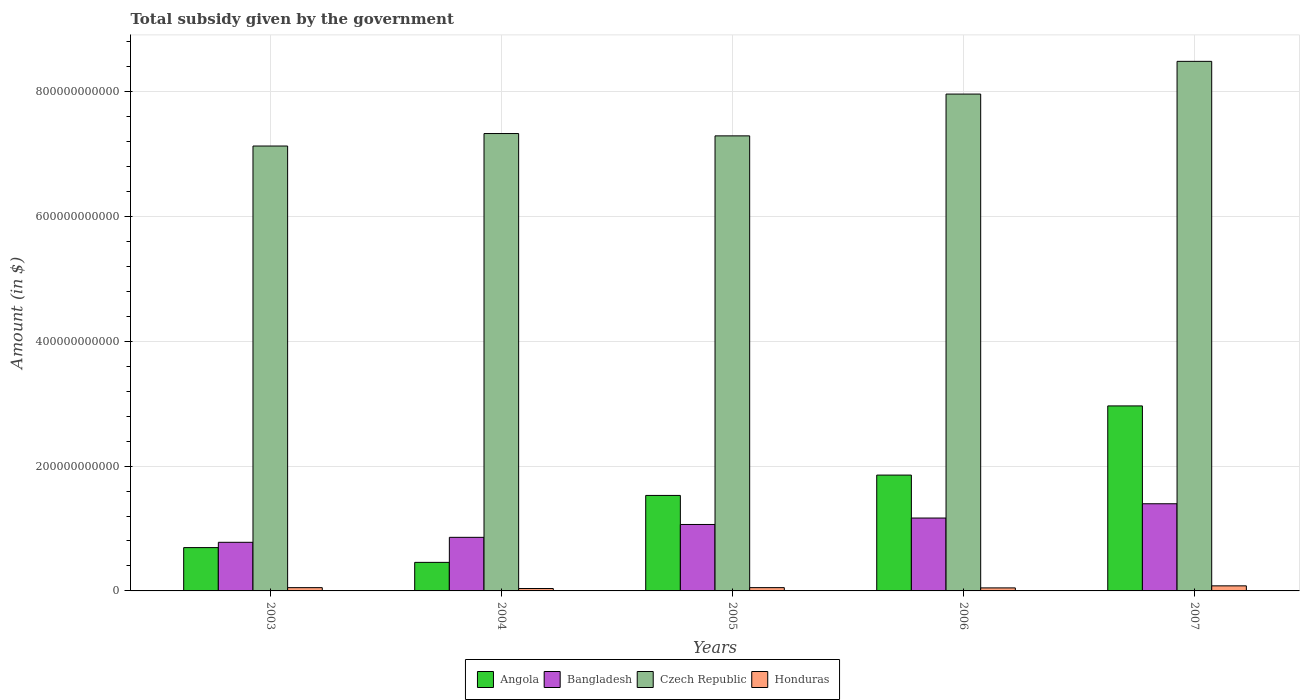Are the number of bars per tick equal to the number of legend labels?
Ensure brevity in your answer.  Yes. Are the number of bars on each tick of the X-axis equal?
Offer a terse response. Yes. How many bars are there on the 1st tick from the left?
Your answer should be very brief. 4. How many bars are there on the 1st tick from the right?
Keep it short and to the point. 4. What is the label of the 4th group of bars from the left?
Give a very brief answer. 2006. What is the total revenue collected by the government in Angola in 2005?
Offer a terse response. 1.53e+11. Across all years, what is the maximum total revenue collected by the government in Czech Republic?
Provide a succinct answer. 8.48e+11. Across all years, what is the minimum total revenue collected by the government in Bangladesh?
Provide a short and direct response. 7.79e+1. In which year was the total revenue collected by the government in Angola minimum?
Your answer should be very brief. 2004. What is the total total revenue collected by the government in Angola in the graph?
Your response must be concise. 7.50e+11. What is the difference between the total revenue collected by the government in Honduras in 2003 and that in 2005?
Offer a very short reply. -1.57e+07. What is the difference between the total revenue collected by the government in Angola in 2005 and the total revenue collected by the government in Bangladesh in 2006?
Provide a succinct answer. 3.62e+1. What is the average total revenue collected by the government in Angola per year?
Make the answer very short. 1.50e+11. In the year 2006, what is the difference between the total revenue collected by the government in Bangladesh and total revenue collected by the government in Czech Republic?
Offer a terse response. -6.79e+11. What is the ratio of the total revenue collected by the government in Angola in 2004 to that in 2005?
Make the answer very short. 0.3. Is the total revenue collected by the government in Bangladesh in 2003 less than that in 2004?
Make the answer very short. Yes. Is the difference between the total revenue collected by the government in Bangladesh in 2004 and 2006 greater than the difference between the total revenue collected by the government in Czech Republic in 2004 and 2006?
Offer a terse response. Yes. What is the difference between the highest and the second highest total revenue collected by the government in Bangladesh?
Your response must be concise. 2.29e+1. What is the difference between the highest and the lowest total revenue collected by the government in Honduras?
Keep it short and to the point. 4.29e+09. In how many years, is the total revenue collected by the government in Honduras greater than the average total revenue collected by the government in Honduras taken over all years?
Your response must be concise. 1. What does the 4th bar from the left in 2006 represents?
Provide a succinct answer. Honduras. What does the 2nd bar from the right in 2006 represents?
Provide a succinct answer. Czech Republic. Is it the case that in every year, the sum of the total revenue collected by the government in Czech Republic and total revenue collected by the government in Angola is greater than the total revenue collected by the government in Bangladesh?
Keep it short and to the point. Yes. What is the difference between two consecutive major ticks on the Y-axis?
Give a very brief answer. 2.00e+11. Does the graph contain any zero values?
Make the answer very short. No. Does the graph contain grids?
Your answer should be compact. Yes. Where does the legend appear in the graph?
Your response must be concise. Bottom center. What is the title of the graph?
Keep it short and to the point. Total subsidy given by the government. Does "Austria" appear as one of the legend labels in the graph?
Give a very brief answer. No. What is the label or title of the X-axis?
Offer a very short reply. Years. What is the label or title of the Y-axis?
Ensure brevity in your answer.  Amount (in $). What is the Amount (in $) of Angola in 2003?
Provide a succinct answer. 6.94e+1. What is the Amount (in $) of Bangladesh in 2003?
Your answer should be compact. 7.79e+1. What is the Amount (in $) in Czech Republic in 2003?
Offer a terse response. 7.13e+11. What is the Amount (in $) in Honduras in 2003?
Provide a short and direct response. 5.25e+09. What is the Amount (in $) in Angola in 2004?
Ensure brevity in your answer.  4.57e+1. What is the Amount (in $) in Bangladesh in 2004?
Provide a succinct answer. 8.59e+1. What is the Amount (in $) in Czech Republic in 2004?
Provide a succinct answer. 7.33e+11. What is the Amount (in $) in Honduras in 2004?
Your response must be concise. 3.84e+09. What is the Amount (in $) of Angola in 2005?
Ensure brevity in your answer.  1.53e+11. What is the Amount (in $) of Bangladesh in 2005?
Provide a succinct answer. 1.06e+11. What is the Amount (in $) in Czech Republic in 2005?
Your answer should be compact. 7.29e+11. What is the Amount (in $) in Honduras in 2005?
Offer a terse response. 5.27e+09. What is the Amount (in $) in Angola in 2006?
Provide a succinct answer. 1.86e+11. What is the Amount (in $) in Bangladesh in 2006?
Ensure brevity in your answer.  1.17e+11. What is the Amount (in $) in Czech Republic in 2006?
Your answer should be compact. 7.96e+11. What is the Amount (in $) of Honduras in 2006?
Ensure brevity in your answer.  4.83e+09. What is the Amount (in $) in Angola in 2007?
Your answer should be compact. 2.96e+11. What is the Amount (in $) of Bangladesh in 2007?
Offer a very short reply. 1.40e+11. What is the Amount (in $) in Czech Republic in 2007?
Make the answer very short. 8.48e+11. What is the Amount (in $) in Honduras in 2007?
Offer a terse response. 8.13e+09. Across all years, what is the maximum Amount (in $) in Angola?
Make the answer very short. 2.96e+11. Across all years, what is the maximum Amount (in $) in Bangladesh?
Provide a succinct answer. 1.40e+11. Across all years, what is the maximum Amount (in $) in Czech Republic?
Your answer should be very brief. 8.48e+11. Across all years, what is the maximum Amount (in $) of Honduras?
Provide a short and direct response. 8.13e+09. Across all years, what is the minimum Amount (in $) in Angola?
Ensure brevity in your answer.  4.57e+1. Across all years, what is the minimum Amount (in $) of Bangladesh?
Provide a succinct answer. 7.79e+1. Across all years, what is the minimum Amount (in $) of Czech Republic?
Your answer should be compact. 7.13e+11. Across all years, what is the minimum Amount (in $) of Honduras?
Make the answer very short. 3.84e+09. What is the total Amount (in $) of Angola in the graph?
Offer a very short reply. 7.50e+11. What is the total Amount (in $) of Bangladesh in the graph?
Ensure brevity in your answer.  5.27e+11. What is the total Amount (in $) of Czech Republic in the graph?
Your response must be concise. 3.82e+12. What is the total Amount (in $) of Honduras in the graph?
Ensure brevity in your answer.  2.73e+1. What is the difference between the Amount (in $) of Angola in 2003 and that in 2004?
Give a very brief answer. 2.37e+1. What is the difference between the Amount (in $) in Bangladesh in 2003 and that in 2004?
Your answer should be very brief. -7.98e+09. What is the difference between the Amount (in $) of Czech Republic in 2003 and that in 2004?
Ensure brevity in your answer.  -2.00e+1. What is the difference between the Amount (in $) in Honduras in 2003 and that in 2004?
Give a very brief answer. 1.41e+09. What is the difference between the Amount (in $) of Angola in 2003 and that in 2005?
Provide a short and direct response. -8.36e+1. What is the difference between the Amount (in $) of Bangladesh in 2003 and that in 2005?
Ensure brevity in your answer.  -2.86e+1. What is the difference between the Amount (in $) of Czech Republic in 2003 and that in 2005?
Your answer should be very brief. -1.63e+1. What is the difference between the Amount (in $) of Honduras in 2003 and that in 2005?
Your response must be concise. -1.57e+07. What is the difference between the Amount (in $) of Angola in 2003 and that in 2006?
Ensure brevity in your answer.  -1.16e+11. What is the difference between the Amount (in $) in Bangladesh in 2003 and that in 2006?
Offer a very short reply. -3.89e+1. What is the difference between the Amount (in $) of Czech Republic in 2003 and that in 2006?
Provide a short and direct response. -8.32e+1. What is the difference between the Amount (in $) of Honduras in 2003 and that in 2006?
Provide a short and direct response. 4.17e+08. What is the difference between the Amount (in $) in Angola in 2003 and that in 2007?
Provide a succinct answer. -2.27e+11. What is the difference between the Amount (in $) in Bangladesh in 2003 and that in 2007?
Make the answer very short. -6.18e+1. What is the difference between the Amount (in $) of Czech Republic in 2003 and that in 2007?
Give a very brief answer. -1.36e+11. What is the difference between the Amount (in $) of Honduras in 2003 and that in 2007?
Offer a very short reply. -2.88e+09. What is the difference between the Amount (in $) of Angola in 2004 and that in 2005?
Your answer should be compact. -1.07e+11. What is the difference between the Amount (in $) in Bangladesh in 2004 and that in 2005?
Ensure brevity in your answer.  -2.06e+1. What is the difference between the Amount (in $) of Czech Republic in 2004 and that in 2005?
Your answer should be very brief. 3.72e+09. What is the difference between the Amount (in $) of Honduras in 2004 and that in 2005?
Make the answer very short. -1.43e+09. What is the difference between the Amount (in $) of Angola in 2004 and that in 2006?
Make the answer very short. -1.40e+11. What is the difference between the Amount (in $) in Bangladesh in 2004 and that in 2006?
Your response must be concise. -3.09e+1. What is the difference between the Amount (in $) in Czech Republic in 2004 and that in 2006?
Provide a short and direct response. -6.32e+1. What is the difference between the Amount (in $) in Honduras in 2004 and that in 2006?
Offer a very short reply. -9.93e+08. What is the difference between the Amount (in $) of Angola in 2004 and that in 2007?
Keep it short and to the point. -2.51e+11. What is the difference between the Amount (in $) of Bangladesh in 2004 and that in 2007?
Your answer should be compact. -5.38e+1. What is the difference between the Amount (in $) of Czech Republic in 2004 and that in 2007?
Your answer should be very brief. -1.16e+11. What is the difference between the Amount (in $) in Honduras in 2004 and that in 2007?
Offer a terse response. -4.29e+09. What is the difference between the Amount (in $) of Angola in 2005 and that in 2006?
Your response must be concise. -3.26e+1. What is the difference between the Amount (in $) in Bangladesh in 2005 and that in 2006?
Your response must be concise. -1.03e+1. What is the difference between the Amount (in $) in Czech Republic in 2005 and that in 2006?
Provide a short and direct response. -6.70e+1. What is the difference between the Amount (in $) of Honduras in 2005 and that in 2006?
Provide a succinct answer. 4.33e+08. What is the difference between the Amount (in $) of Angola in 2005 and that in 2007?
Keep it short and to the point. -1.43e+11. What is the difference between the Amount (in $) of Bangladesh in 2005 and that in 2007?
Your answer should be very brief. -3.32e+1. What is the difference between the Amount (in $) of Czech Republic in 2005 and that in 2007?
Give a very brief answer. -1.19e+11. What is the difference between the Amount (in $) in Honduras in 2005 and that in 2007?
Offer a very short reply. -2.87e+09. What is the difference between the Amount (in $) in Angola in 2006 and that in 2007?
Your answer should be compact. -1.11e+11. What is the difference between the Amount (in $) in Bangladesh in 2006 and that in 2007?
Your answer should be compact. -2.29e+1. What is the difference between the Amount (in $) of Czech Republic in 2006 and that in 2007?
Ensure brevity in your answer.  -5.24e+1. What is the difference between the Amount (in $) in Honduras in 2006 and that in 2007?
Provide a short and direct response. -3.30e+09. What is the difference between the Amount (in $) in Angola in 2003 and the Amount (in $) in Bangladesh in 2004?
Offer a terse response. -1.65e+1. What is the difference between the Amount (in $) in Angola in 2003 and the Amount (in $) in Czech Republic in 2004?
Your answer should be very brief. -6.63e+11. What is the difference between the Amount (in $) in Angola in 2003 and the Amount (in $) in Honduras in 2004?
Ensure brevity in your answer.  6.56e+1. What is the difference between the Amount (in $) of Bangladesh in 2003 and the Amount (in $) of Czech Republic in 2004?
Your answer should be compact. -6.55e+11. What is the difference between the Amount (in $) of Bangladesh in 2003 and the Amount (in $) of Honduras in 2004?
Offer a very short reply. 7.40e+1. What is the difference between the Amount (in $) of Czech Republic in 2003 and the Amount (in $) of Honduras in 2004?
Provide a short and direct response. 7.09e+11. What is the difference between the Amount (in $) in Angola in 2003 and the Amount (in $) in Bangladesh in 2005?
Provide a short and direct response. -3.71e+1. What is the difference between the Amount (in $) in Angola in 2003 and the Amount (in $) in Czech Republic in 2005?
Provide a short and direct response. -6.60e+11. What is the difference between the Amount (in $) of Angola in 2003 and the Amount (in $) of Honduras in 2005?
Provide a succinct answer. 6.41e+1. What is the difference between the Amount (in $) in Bangladesh in 2003 and the Amount (in $) in Czech Republic in 2005?
Keep it short and to the point. -6.51e+11. What is the difference between the Amount (in $) of Bangladesh in 2003 and the Amount (in $) of Honduras in 2005?
Make the answer very short. 7.26e+1. What is the difference between the Amount (in $) of Czech Republic in 2003 and the Amount (in $) of Honduras in 2005?
Make the answer very short. 7.07e+11. What is the difference between the Amount (in $) in Angola in 2003 and the Amount (in $) in Bangladesh in 2006?
Your answer should be very brief. -4.74e+1. What is the difference between the Amount (in $) in Angola in 2003 and the Amount (in $) in Czech Republic in 2006?
Make the answer very short. -7.27e+11. What is the difference between the Amount (in $) of Angola in 2003 and the Amount (in $) of Honduras in 2006?
Offer a very short reply. 6.46e+1. What is the difference between the Amount (in $) in Bangladesh in 2003 and the Amount (in $) in Czech Republic in 2006?
Ensure brevity in your answer.  -7.18e+11. What is the difference between the Amount (in $) in Bangladesh in 2003 and the Amount (in $) in Honduras in 2006?
Ensure brevity in your answer.  7.30e+1. What is the difference between the Amount (in $) in Czech Republic in 2003 and the Amount (in $) in Honduras in 2006?
Keep it short and to the point. 7.08e+11. What is the difference between the Amount (in $) in Angola in 2003 and the Amount (in $) in Bangladesh in 2007?
Offer a very short reply. -7.02e+1. What is the difference between the Amount (in $) in Angola in 2003 and the Amount (in $) in Czech Republic in 2007?
Offer a terse response. -7.79e+11. What is the difference between the Amount (in $) of Angola in 2003 and the Amount (in $) of Honduras in 2007?
Your answer should be compact. 6.13e+1. What is the difference between the Amount (in $) of Bangladesh in 2003 and the Amount (in $) of Czech Republic in 2007?
Keep it short and to the point. -7.71e+11. What is the difference between the Amount (in $) in Bangladesh in 2003 and the Amount (in $) in Honduras in 2007?
Keep it short and to the point. 6.97e+1. What is the difference between the Amount (in $) in Czech Republic in 2003 and the Amount (in $) in Honduras in 2007?
Your answer should be compact. 7.05e+11. What is the difference between the Amount (in $) of Angola in 2004 and the Amount (in $) of Bangladesh in 2005?
Offer a terse response. -6.07e+1. What is the difference between the Amount (in $) in Angola in 2004 and the Amount (in $) in Czech Republic in 2005?
Make the answer very short. -6.83e+11. What is the difference between the Amount (in $) of Angola in 2004 and the Amount (in $) of Honduras in 2005?
Your response must be concise. 4.05e+1. What is the difference between the Amount (in $) in Bangladesh in 2004 and the Amount (in $) in Czech Republic in 2005?
Keep it short and to the point. -6.43e+11. What is the difference between the Amount (in $) of Bangladesh in 2004 and the Amount (in $) of Honduras in 2005?
Your response must be concise. 8.06e+1. What is the difference between the Amount (in $) of Czech Republic in 2004 and the Amount (in $) of Honduras in 2005?
Your response must be concise. 7.27e+11. What is the difference between the Amount (in $) in Angola in 2004 and the Amount (in $) in Bangladesh in 2006?
Keep it short and to the point. -7.10e+1. What is the difference between the Amount (in $) in Angola in 2004 and the Amount (in $) in Czech Republic in 2006?
Your answer should be very brief. -7.50e+11. What is the difference between the Amount (in $) of Angola in 2004 and the Amount (in $) of Honduras in 2006?
Keep it short and to the point. 4.09e+1. What is the difference between the Amount (in $) in Bangladesh in 2004 and the Amount (in $) in Czech Republic in 2006?
Your answer should be compact. -7.10e+11. What is the difference between the Amount (in $) of Bangladesh in 2004 and the Amount (in $) of Honduras in 2006?
Give a very brief answer. 8.10e+1. What is the difference between the Amount (in $) in Czech Republic in 2004 and the Amount (in $) in Honduras in 2006?
Give a very brief answer. 7.28e+11. What is the difference between the Amount (in $) of Angola in 2004 and the Amount (in $) of Bangladesh in 2007?
Your response must be concise. -9.39e+1. What is the difference between the Amount (in $) of Angola in 2004 and the Amount (in $) of Czech Republic in 2007?
Offer a terse response. -8.03e+11. What is the difference between the Amount (in $) of Angola in 2004 and the Amount (in $) of Honduras in 2007?
Offer a terse response. 3.76e+1. What is the difference between the Amount (in $) in Bangladesh in 2004 and the Amount (in $) in Czech Republic in 2007?
Your answer should be very brief. -7.63e+11. What is the difference between the Amount (in $) of Bangladesh in 2004 and the Amount (in $) of Honduras in 2007?
Offer a terse response. 7.77e+1. What is the difference between the Amount (in $) in Czech Republic in 2004 and the Amount (in $) in Honduras in 2007?
Offer a terse response. 7.25e+11. What is the difference between the Amount (in $) in Angola in 2005 and the Amount (in $) in Bangladesh in 2006?
Keep it short and to the point. 3.62e+1. What is the difference between the Amount (in $) of Angola in 2005 and the Amount (in $) of Czech Republic in 2006?
Give a very brief answer. -6.43e+11. What is the difference between the Amount (in $) of Angola in 2005 and the Amount (in $) of Honduras in 2006?
Give a very brief answer. 1.48e+11. What is the difference between the Amount (in $) in Bangladesh in 2005 and the Amount (in $) in Czech Republic in 2006?
Keep it short and to the point. -6.90e+11. What is the difference between the Amount (in $) of Bangladesh in 2005 and the Amount (in $) of Honduras in 2006?
Make the answer very short. 1.02e+11. What is the difference between the Amount (in $) of Czech Republic in 2005 and the Amount (in $) of Honduras in 2006?
Make the answer very short. 7.24e+11. What is the difference between the Amount (in $) in Angola in 2005 and the Amount (in $) in Bangladesh in 2007?
Keep it short and to the point. 1.34e+1. What is the difference between the Amount (in $) in Angola in 2005 and the Amount (in $) in Czech Republic in 2007?
Your response must be concise. -6.95e+11. What is the difference between the Amount (in $) in Angola in 2005 and the Amount (in $) in Honduras in 2007?
Provide a succinct answer. 1.45e+11. What is the difference between the Amount (in $) of Bangladesh in 2005 and the Amount (in $) of Czech Republic in 2007?
Provide a succinct answer. -7.42e+11. What is the difference between the Amount (in $) in Bangladesh in 2005 and the Amount (in $) in Honduras in 2007?
Your response must be concise. 9.83e+1. What is the difference between the Amount (in $) in Czech Republic in 2005 and the Amount (in $) in Honduras in 2007?
Ensure brevity in your answer.  7.21e+11. What is the difference between the Amount (in $) in Angola in 2006 and the Amount (in $) in Bangladesh in 2007?
Keep it short and to the point. 4.59e+1. What is the difference between the Amount (in $) in Angola in 2006 and the Amount (in $) in Czech Republic in 2007?
Provide a short and direct response. -6.63e+11. What is the difference between the Amount (in $) of Angola in 2006 and the Amount (in $) of Honduras in 2007?
Give a very brief answer. 1.77e+11. What is the difference between the Amount (in $) of Bangladesh in 2006 and the Amount (in $) of Czech Republic in 2007?
Offer a very short reply. -7.32e+11. What is the difference between the Amount (in $) in Bangladesh in 2006 and the Amount (in $) in Honduras in 2007?
Offer a terse response. 1.09e+11. What is the difference between the Amount (in $) of Czech Republic in 2006 and the Amount (in $) of Honduras in 2007?
Ensure brevity in your answer.  7.88e+11. What is the average Amount (in $) of Angola per year?
Make the answer very short. 1.50e+11. What is the average Amount (in $) of Bangladesh per year?
Provide a succinct answer. 1.05e+11. What is the average Amount (in $) in Czech Republic per year?
Your response must be concise. 7.64e+11. What is the average Amount (in $) of Honduras per year?
Your answer should be very brief. 5.47e+09. In the year 2003, what is the difference between the Amount (in $) of Angola and Amount (in $) of Bangladesh?
Keep it short and to the point. -8.48e+09. In the year 2003, what is the difference between the Amount (in $) of Angola and Amount (in $) of Czech Republic?
Ensure brevity in your answer.  -6.43e+11. In the year 2003, what is the difference between the Amount (in $) in Angola and Amount (in $) in Honduras?
Your answer should be very brief. 6.42e+1. In the year 2003, what is the difference between the Amount (in $) in Bangladesh and Amount (in $) in Czech Republic?
Offer a very short reply. -6.35e+11. In the year 2003, what is the difference between the Amount (in $) in Bangladesh and Amount (in $) in Honduras?
Offer a terse response. 7.26e+1. In the year 2003, what is the difference between the Amount (in $) in Czech Republic and Amount (in $) in Honduras?
Offer a terse response. 7.08e+11. In the year 2004, what is the difference between the Amount (in $) in Angola and Amount (in $) in Bangladesh?
Your response must be concise. -4.01e+1. In the year 2004, what is the difference between the Amount (in $) of Angola and Amount (in $) of Czech Republic?
Ensure brevity in your answer.  -6.87e+11. In the year 2004, what is the difference between the Amount (in $) of Angola and Amount (in $) of Honduras?
Provide a short and direct response. 4.19e+1. In the year 2004, what is the difference between the Amount (in $) in Bangladesh and Amount (in $) in Czech Republic?
Ensure brevity in your answer.  -6.47e+11. In the year 2004, what is the difference between the Amount (in $) of Bangladesh and Amount (in $) of Honduras?
Keep it short and to the point. 8.20e+1. In the year 2004, what is the difference between the Amount (in $) of Czech Republic and Amount (in $) of Honduras?
Keep it short and to the point. 7.29e+11. In the year 2005, what is the difference between the Amount (in $) in Angola and Amount (in $) in Bangladesh?
Keep it short and to the point. 4.65e+1. In the year 2005, what is the difference between the Amount (in $) in Angola and Amount (in $) in Czech Republic?
Give a very brief answer. -5.76e+11. In the year 2005, what is the difference between the Amount (in $) in Angola and Amount (in $) in Honduras?
Your answer should be very brief. 1.48e+11. In the year 2005, what is the difference between the Amount (in $) of Bangladesh and Amount (in $) of Czech Republic?
Your answer should be very brief. -6.23e+11. In the year 2005, what is the difference between the Amount (in $) of Bangladesh and Amount (in $) of Honduras?
Make the answer very short. 1.01e+11. In the year 2005, what is the difference between the Amount (in $) of Czech Republic and Amount (in $) of Honduras?
Give a very brief answer. 7.24e+11. In the year 2006, what is the difference between the Amount (in $) of Angola and Amount (in $) of Bangladesh?
Offer a terse response. 6.88e+1. In the year 2006, what is the difference between the Amount (in $) in Angola and Amount (in $) in Czech Republic?
Provide a short and direct response. -6.10e+11. In the year 2006, what is the difference between the Amount (in $) of Angola and Amount (in $) of Honduras?
Your answer should be very brief. 1.81e+11. In the year 2006, what is the difference between the Amount (in $) in Bangladesh and Amount (in $) in Czech Republic?
Provide a succinct answer. -6.79e+11. In the year 2006, what is the difference between the Amount (in $) of Bangladesh and Amount (in $) of Honduras?
Give a very brief answer. 1.12e+11. In the year 2006, what is the difference between the Amount (in $) of Czech Republic and Amount (in $) of Honduras?
Your response must be concise. 7.91e+11. In the year 2007, what is the difference between the Amount (in $) in Angola and Amount (in $) in Bangladesh?
Keep it short and to the point. 1.57e+11. In the year 2007, what is the difference between the Amount (in $) of Angola and Amount (in $) of Czech Republic?
Provide a short and direct response. -5.52e+11. In the year 2007, what is the difference between the Amount (in $) in Angola and Amount (in $) in Honduras?
Offer a terse response. 2.88e+11. In the year 2007, what is the difference between the Amount (in $) in Bangladesh and Amount (in $) in Czech Republic?
Provide a short and direct response. -7.09e+11. In the year 2007, what is the difference between the Amount (in $) in Bangladesh and Amount (in $) in Honduras?
Make the answer very short. 1.32e+11. In the year 2007, what is the difference between the Amount (in $) of Czech Republic and Amount (in $) of Honduras?
Your response must be concise. 8.40e+11. What is the ratio of the Amount (in $) of Angola in 2003 to that in 2004?
Give a very brief answer. 1.52. What is the ratio of the Amount (in $) of Bangladesh in 2003 to that in 2004?
Ensure brevity in your answer.  0.91. What is the ratio of the Amount (in $) of Czech Republic in 2003 to that in 2004?
Give a very brief answer. 0.97. What is the ratio of the Amount (in $) of Honduras in 2003 to that in 2004?
Your answer should be very brief. 1.37. What is the ratio of the Amount (in $) in Angola in 2003 to that in 2005?
Provide a short and direct response. 0.45. What is the ratio of the Amount (in $) in Bangladesh in 2003 to that in 2005?
Your response must be concise. 0.73. What is the ratio of the Amount (in $) of Czech Republic in 2003 to that in 2005?
Offer a terse response. 0.98. What is the ratio of the Amount (in $) of Honduras in 2003 to that in 2005?
Keep it short and to the point. 1. What is the ratio of the Amount (in $) in Angola in 2003 to that in 2006?
Your answer should be compact. 0.37. What is the ratio of the Amount (in $) of Bangladesh in 2003 to that in 2006?
Keep it short and to the point. 0.67. What is the ratio of the Amount (in $) of Czech Republic in 2003 to that in 2006?
Offer a very short reply. 0.9. What is the ratio of the Amount (in $) of Honduras in 2003 to that in 2006?
Provide a succinct answer. 1.09. What is the ratio of the Amount (in $) in Angola in 2003 to that in 2007?
Provide a short and direct response. 0.23. What is the ratio of the Amount (in $) in Bangladesh in 2003 to that in 2007?
Your answer should be very brief. 0.56. What is the ratio of the Amount (in $) in Czech Republic in 2003 to that in 2007?
Your answer should be very brief. 0.84. What is the ratio of the Amount (in $) of Honduras in 2003 to that in 2007?
Offer a very short reply. 0.65. What is the ratio of the Amount (in $) in Angola in 2004 to that in 2005?
Your answer should be very brief. 0.3. What is the ratio of the Amount (in $) of Bangladesh in 2004 to that in 2005?
Your response must be concise. 0.81. What is the ratio of the Amount (in $) in Honduras in 2004 to that in 2005?
Make the answer very short. 0.73. What is the ratio of the Amount (in $) of Angola in 2004 to that in 2006?
Provide a succinct answer. 0.25. What is the ratio of the Amount (in $) in Bangladesh in 2004 to that in 2006?
Provide a short and direct response. 0.74. What is the ratio of the Amount (in $) of Czech Republic in 2004 to that in 2006?
Your answer should be very brief. 0.92. What is the ratio of the Amount (in $) in Honduras in 2004 to that in 2006?
Ensure brevity in your answer.  0.79. What is the ratio of the Amount (in $) of Angola in 2004 to that in 2007?
Give a very brief answer. 0.15. What is the ratio of the Amount (in $) in Bangladesh in 2004 to that in 2007?
Ensure brevity in your answer.  0.61. What is the ratio of the Amount (in $) of Czech Republic in 2004 to that in 2007?
Provide a short and direct response. 0.86. What is the ratio of the Amount (in $) of Honduras in 2004 to that in 2007?
Make the answer very short. 0.47. What is the ratio of the Amount (in $) in Angola in 2005 to that in 2006?
Provide a succinct answer. 0.82. What is the ratio of the Amount (in $) of Bangladesh in 2005 to that in 2006?
Ensure brevity in your answer.  0.91. What is the ratio of the Amount (in $) in Czech Republic in 2005 to that in 2006?
Your answer should be compact. 0.92. What is the ratio of the Amount (in $) in Honduras in 2005 to that in 2006?
Your answer should be compact. 1.09. What is the ratio of the Amount (in $) in Angola in 2005 to that in 2007?
Make the answer very short. 0.52. What is the ratio of the Amount (in $) of Bangladesh in 2005 to that in 2007?
Offer a terse response. 0.76. What is the ratio of the Amount (in $) of Czech Republic in 2005 to that in 2007?
Your answer should be compact. 0.86. What is the ratio of the Amount (in $) of Honduras in 2005 to that in 2007?
Your answer should be very brief. 0.65. What is the ratio of the Amount (in $) of Angola in 2006 to that in 2007?
Give a very brief answer. 0.63. What is the ratio of the Amount (in $) in Bangladesh in 2006 to that in 2007?
Your response must be concise. 0.84. What is the ratio of the Amount (in $) of Czech Republic in 2006 to that in 2007?
Provide a short and direct response. 0.94. What is the ratio of the Amount (in $) of Honduras in 2006 to that in 2007?
Offer a very short reply. 0.59. What is the difference between the highest and the second highest Amount (in $) in Angola?
Make the answer very short. 1.11e+11. What is the difference between the highest and the second highest Amount (in $) of Bangladesh?
Provide a short and direct response. 2.29e+1. What is the difference between the highest and the second highest Amount (in $) in Czech Republic?
Keep it short and to the point. 5.24e+1. What is the difference between the highest and the second highest Amount (in $) in Honduras?
Offer a terse response. 2.87e+09. What is the difference between the highest and the lowest Amount (in $) in Angola?
Provide a succinct answer. 2.51e+11. What is the difference between the highest and the lowest Amount (in $) in Bangladesh?
Ensure brevity in your answer.  6.18e+1. What is the difference between the highest and the lowest Amount (in $) in Czech Republic?
Provide a succinct answer. 1.36e+11. What is the difference between the highest and the lowest Amount (in $) in Honduras?
Provide a succinct answer. 4.29e+09. 